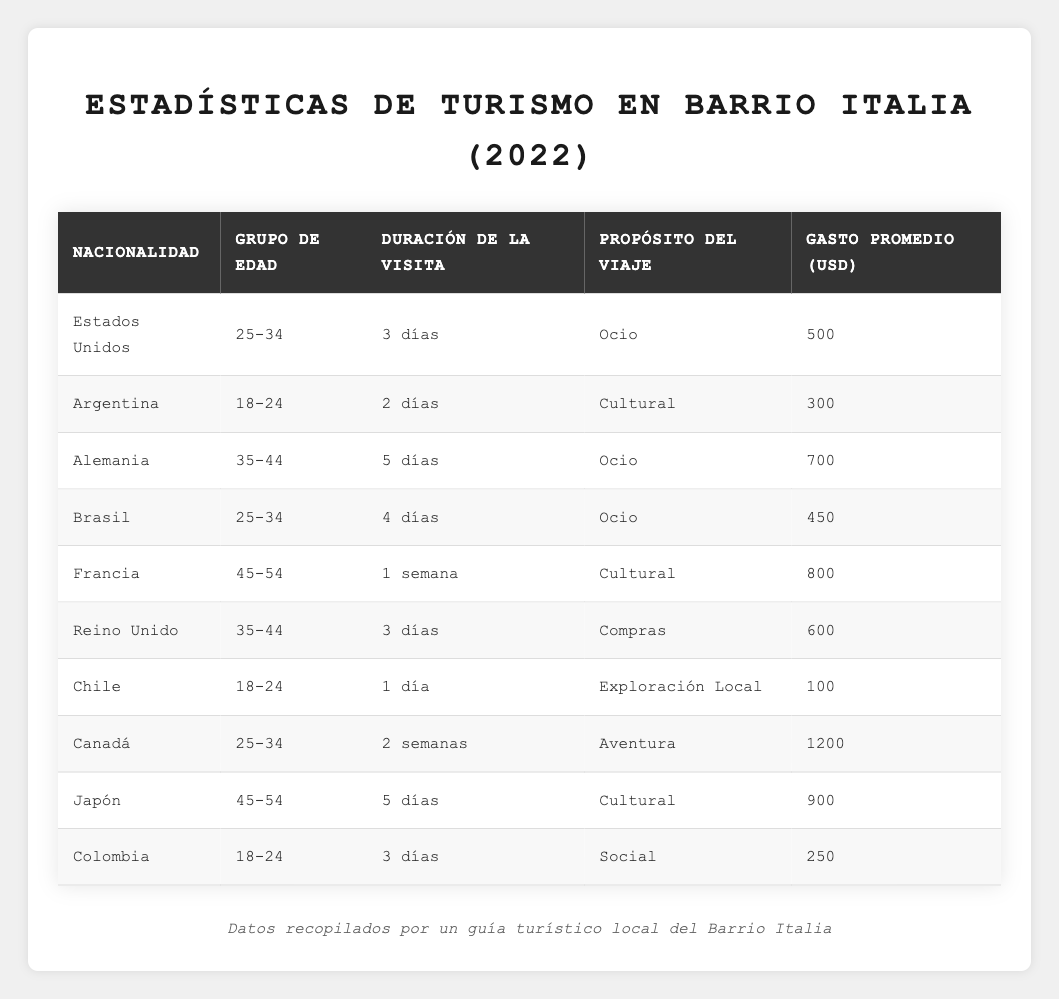¿Cuántos días dura en promedio la visita de los turistas de Estados Unidos? Hay un registro de un turista de Estados Unidos cuya duración de visita es de 3 días. Por lo tanto, el promedio para esta nacionalidad es de 3 días.
Answer: 3 días ¿Cuál es el gasto promedio de los turistas de Brasil? El gasto promedio de los turistas de Brasil es de 450 USD, como se indica en la tabla.
Answer: 450 USD ¿Es cierto que los turistas de Argentina son los que menos gastan? Al observar la tabla, el gasto promedio de los turistas de Argentina es de 300 USD, que es el menos comparado con las otras nacionalidades. Por lo tanto, la afirmación es verdadera.
Answer: Sí ¿Cuántos días en total visitaron los turistas de Chile y Colombia? El turista de Chile visitó por 1 día y el de Colombia por 3 días. Entonces, sumando ambos (1 + 3), la cantidad total es de 4 días.
Answer: 4 días ¿Cuál es la nacionalidad que gasta más y cuánto es? Al revisar los datos, el turista de Canadá tiene el mayor gasto promedio de 1200 USD, lo que indica que es la nacionalidad que gasta más.
Answer: Canadá, 1200 USD ¿Qué porcentaje de los turistas visitan por ocio? Hay 4 turistas que indican ocio como propósito de viaje (Estados Unidos, Alemania, Brasil y el Reino Unido) de un total de 10 turistas. Así que el porcentaje es (4/10) * 100 = 40%.
Answer: 40% ¿Cuál es la diferencia en gasto promedio entre turistas de Japón y Alemania? El gasto promedio de Japón es 900 USD y de Alemania es 700 USD. La diferencia es (900 - 700) = 200 USD.
Answer: 200 USD ¿Hay más turistas de 18-24 años que de 45-54 años? Hay 3 turistas en el grupo de 18-24 años (Argentina, Chile y Colombia) y 3 en el de 45-54 años (Francia y Japón). Esto indica que no hay más turistas en uno de los grupos; son iguales.
Answer: No ¿Los turistas de Canadá pasan más días que los de Francia? El turista de Canadá tiene una duración de 2 semanas (14 días), mientras que el turista de Francia tiene una duración de 1 semana (7 días). Así que, efectivamente, los de Canadá pasan más días.
Answer: Sí ¿Quiénes tienen el promedio de gasto más bajo y qué edad tienen? El turista de Chile, con un gasto de 100 USD, tiene el promedio de gasto más bajo y pertenece al grupo de edad 18-24 años.
Answer: Chile, 100 USD, 18-24 años ¿Cuál es la edad promedio de los turistas que visitaron por aventura? El único turista que visitó por aventura es el de Canadá, que está en el grupo de edad 25-34 años. Esto determina que la edad promedio para ese propósito es 25-34 años.
Answer: 25-34 años 